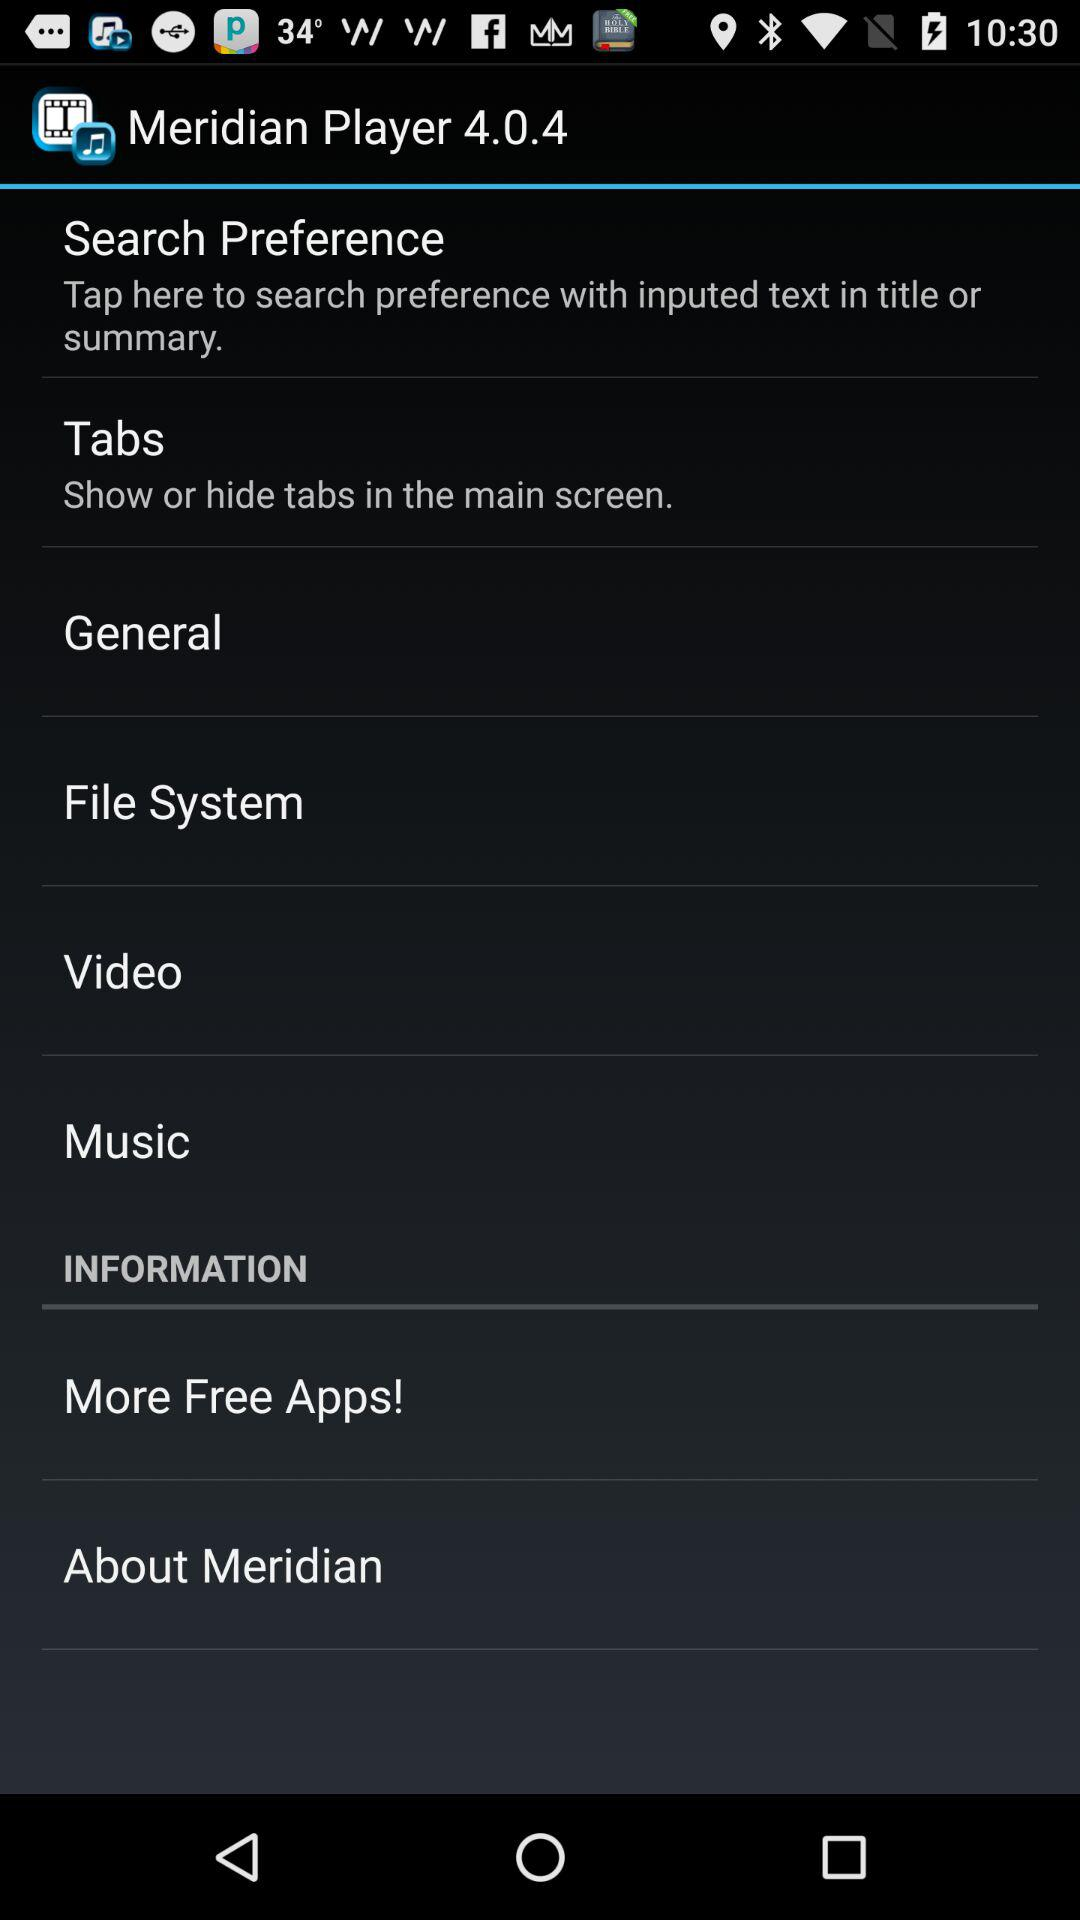What is the name of the application? The name of the application is "Meridian Player 4.0.4". 